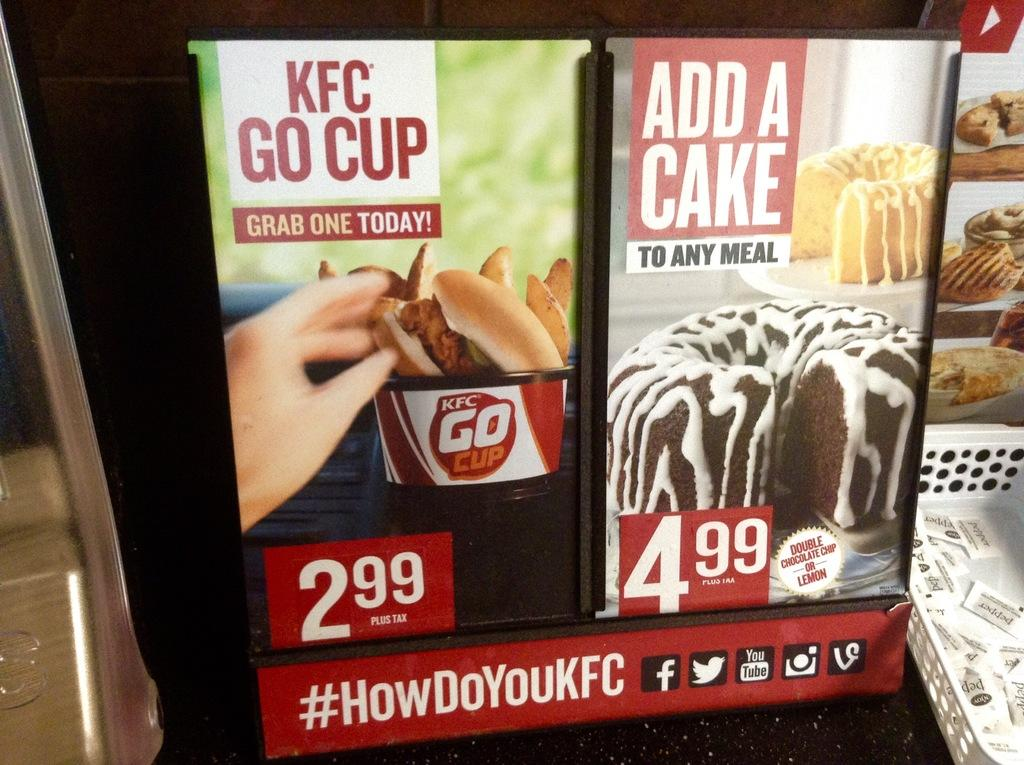What type of objects can be seen in the image? There are boards, a basket, and packets visible in the image. What is the purpose of the basket in the image? The purpose of the basket cannot be determined from the image alone. What is present on the boards in the image? Images, logos, and writing are present on the boards in the image. What type of berry is being used to decorate the basket in the image? There are no berries present in the image; the basket is empty. What type of journey is depicted in the image? There is no journey depicted in the image; it features boards, a basket, packets, and the details on the boards. 